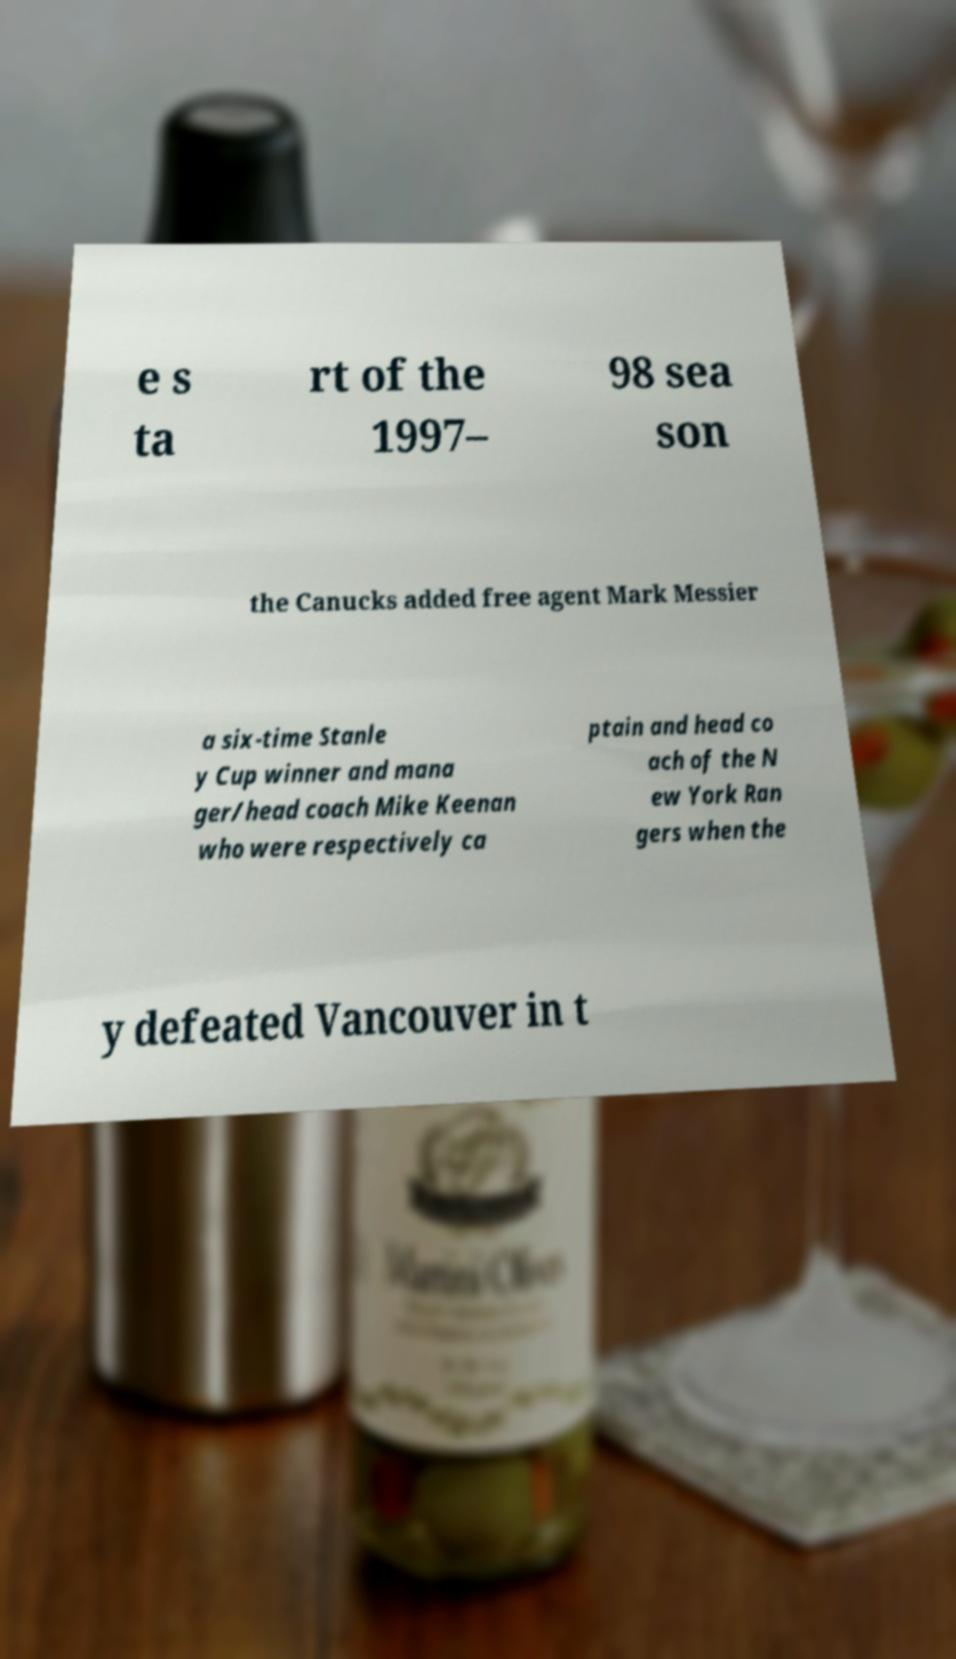Please read and relay the text visible in this image. What does it say? e s ta rt of the 1997– 98 sea son the Canucks added free agent Mark Messier a six-time Stanle y Cup winner and mana ger/head coach Mike Keenan who were respectively ca ptain and head co ach of the N ew York Ran gers when the y defeated Vancouver in t 